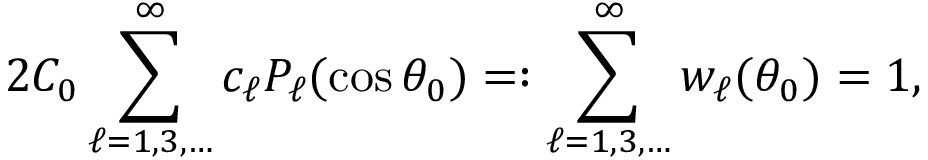<formula> <loc_0><loc_0><loc_500><loc_500>2 C _ { 0 } \sum _ { \ell = 1 , 3 , \dots } ^ { \infty } c _ { \ell } P _ { \ell } ( \cos \theta _ { 0 } ) = \colon \sum _ { \ell = 1 , 3 , \dots } ^ { \infty } w _ { \ell } ( \theta _ { 0 } ) = 1 ,</formula> 